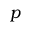<formula> <loc_0><loc_0><loc_500><loc_500>p</formula> 